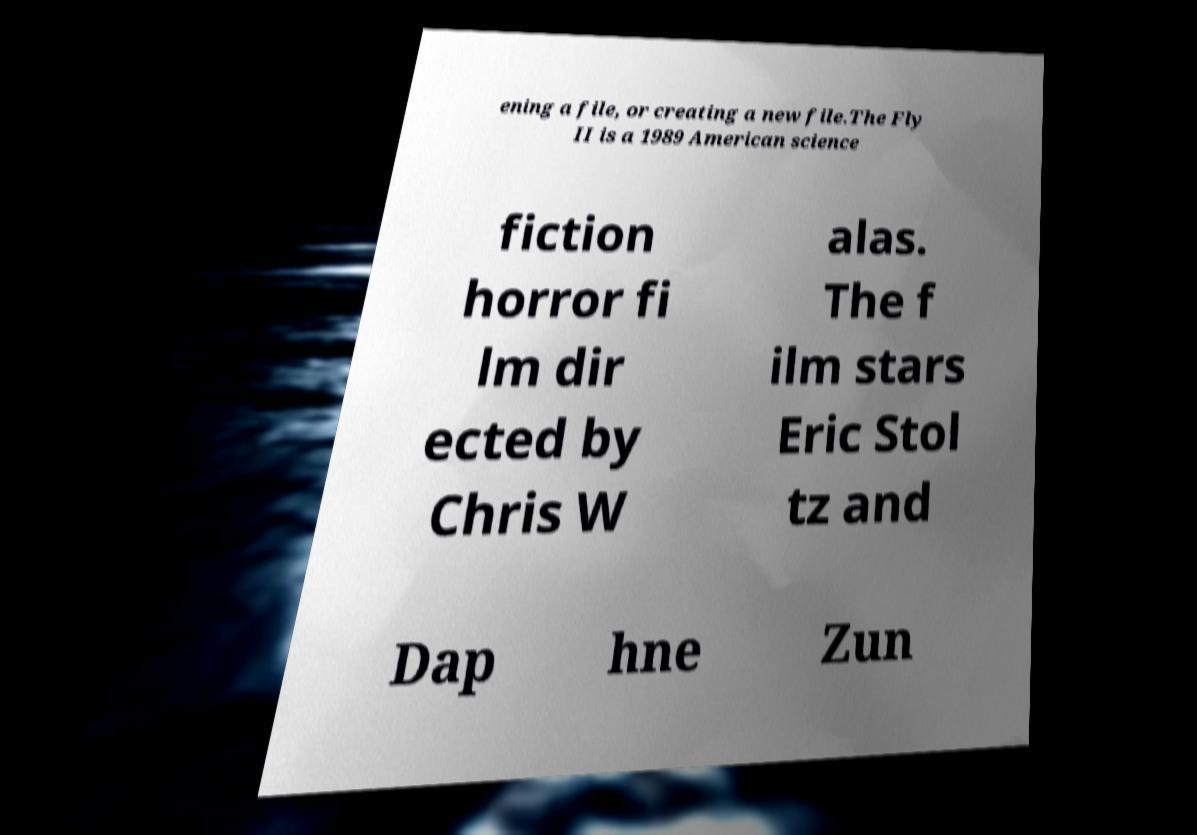Could you extract and type out the text from this image? ening a file, or creating a new file.The Fly II is a 1989 American science fiction horror fi lm dir ected by Chris W alas. The f ilm stars Eric Stol tz and Dap hne Zun 